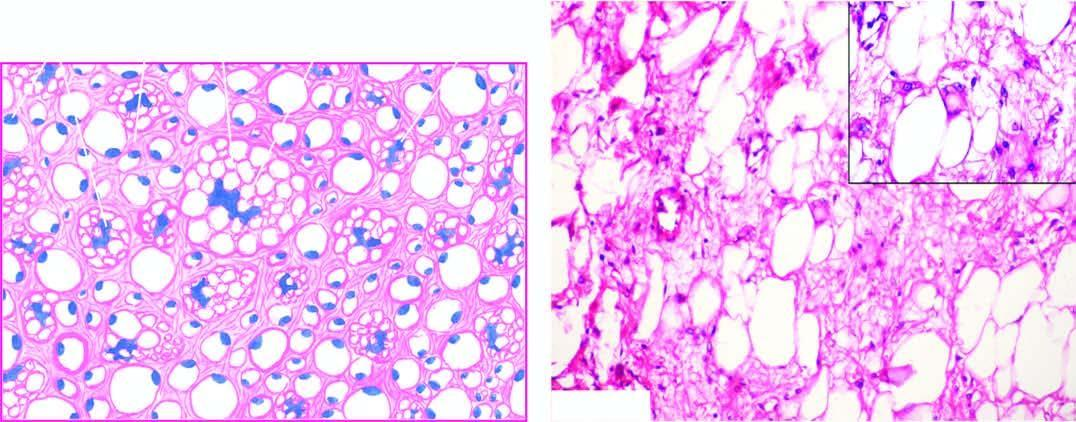what does the tumour show?
Answer the question using a single word or phrase. Characteristic 